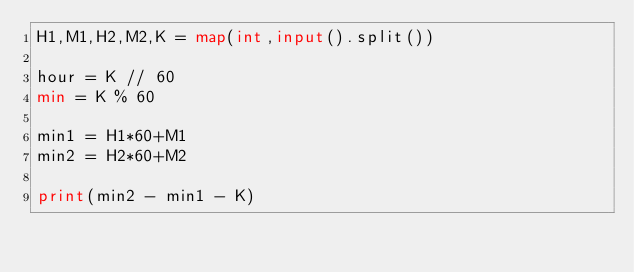<code> <loc_0><loc_0><loc_500><loc_500><_Python_>H1,M1,H2,M2,K = map(int,input().split())

hour = K // 60
min = K % 60

min1 = H1*60+M1
min2 = H2*60+M2

print(min2 - min1 - K)</code> 